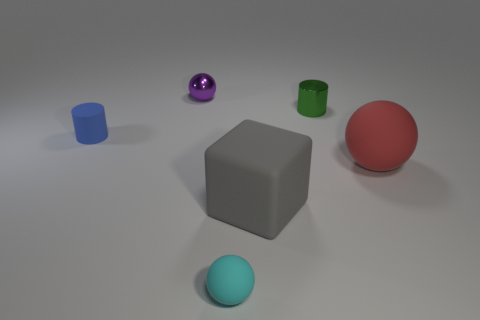There is a sphere that is behind the small cyan sphere and to the right of the small purple metallic sphere; what size is it?
Offer a terse response. Large. What number of objects are there?
Offer a terse response. 6. What number of cubes are either large brown things or small green objects?
Give a very brief answer. 0. There is a big gray cube left of the tiny cylinder right of the tiny blue thing; what number of small cylinders are on the left side of it?
Offer a terse response. 1. What is the color of the matte ball that is the same size as the blue cylinder?
Make the answer very short. Cyan. Is the number of tiny blue cylinders behind the purple shiny thing greater than the number of blue objects?
Keep it short and to the point. No. Do the tiny green object and the tiny cyan sphere have the same material?
Provide a succinct answer. No. What number of objects are tiny objects in front of the big matte ball or big blocks?
Offer a terse response. 2. What number of other things are the same size as the gray rubber cube?
Offer a very short reply. 1. Are there the same number of purple balls in front of the small blue cylinder and green metal objects right of the tiny green cylinder?
Give a very brief answer. Yes. 